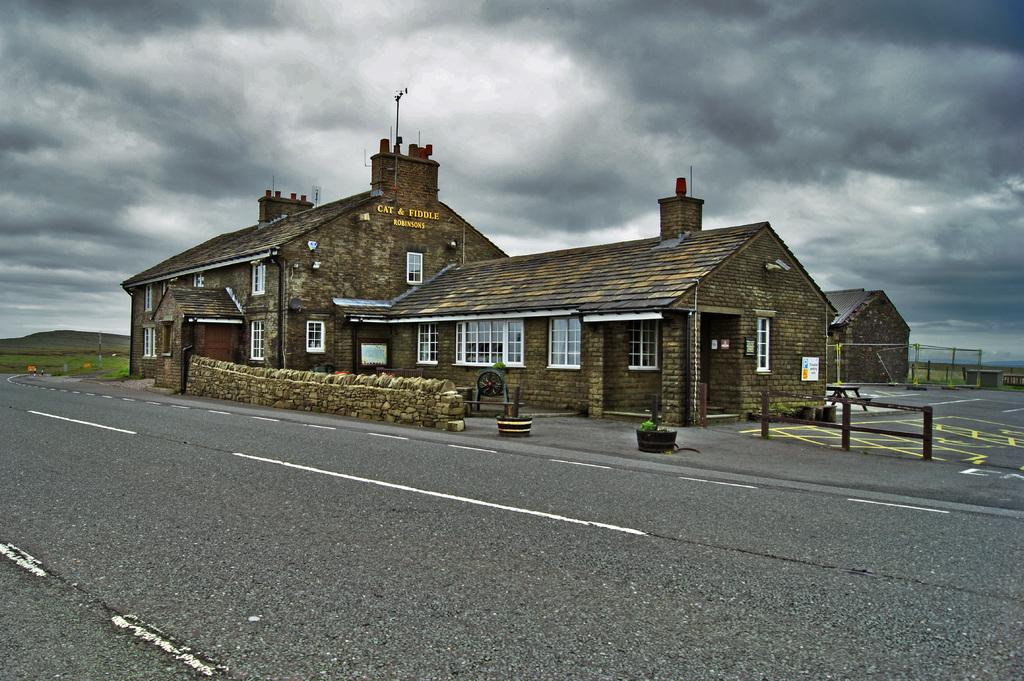What type of structures are visible in the image? There are buildings with windows in the image. What can be seen on the buildings? There is a name board on one of the buildings. What is located at the bottom of the image? There is a road at the bottom of the image. What is visible in the background of the image? The sky is visible in the background of the image. How would you describe the sky in the image? The sky appears to be cloudy. What type of ring can be seen on the school in the image? There is no ring or school present in the image. What type of thing is depicted on the buildings in the image? The buildings in the image have windows and a name board, but there is no specific "thing" depicted on them. 